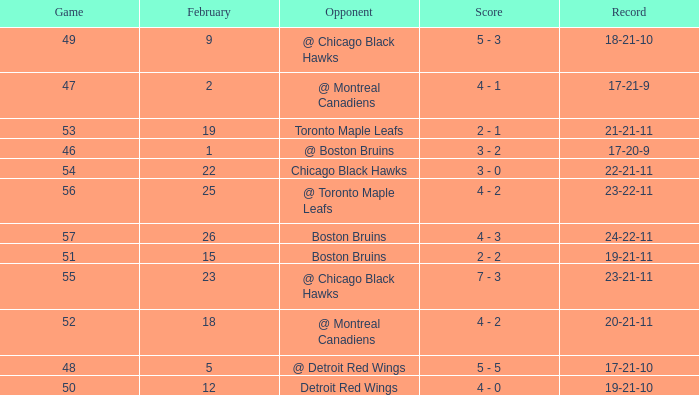What was the score of the game 57 after February 23? 4 - 3. 